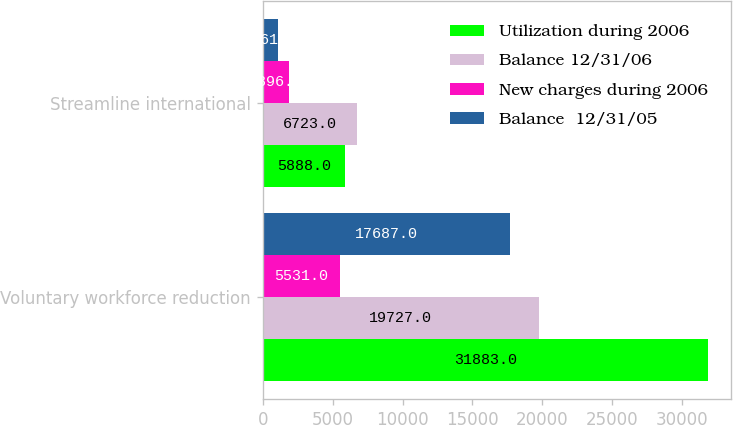Convert chart to OTSL. <chart><loc_0><loc_0><loc_500><loc_500><stacked_bar_chart><ecel><fcel>Voluntary workforce reduction<fcel>Streamline international<nl><fcel>Utilization during 2006<fcel>31883<fcel>5888<nl><fcel>Balance 12/31/06<fcel>19727<fcel>6723<nl><fcel>New charges during 2006<fcel>5531<fcel>1896<nl><fcel>Balance  12/31/05<fcel>17687<fcel>1061<nl></chart> 